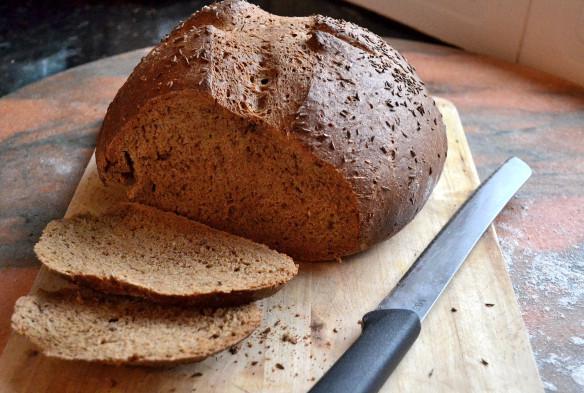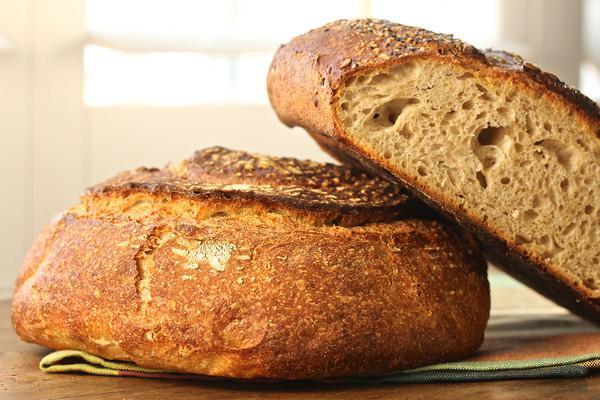The first image is the image on the left, the second image is the image on the right. Analyze the images presented: Is the assertion "The bread in the image on the left has already been sliced." valid? Answer yes or no. Yes. The first image is the image on the left, the second image is the image on the right. Given the left and right images, does the statement "The left image includes at least two slices of bread overlapping in front of a cut loaf, and the right image shows one flat-bottomed round bread leaning against one that is sitting flat." hold true? Answer yes or no. Yes. 